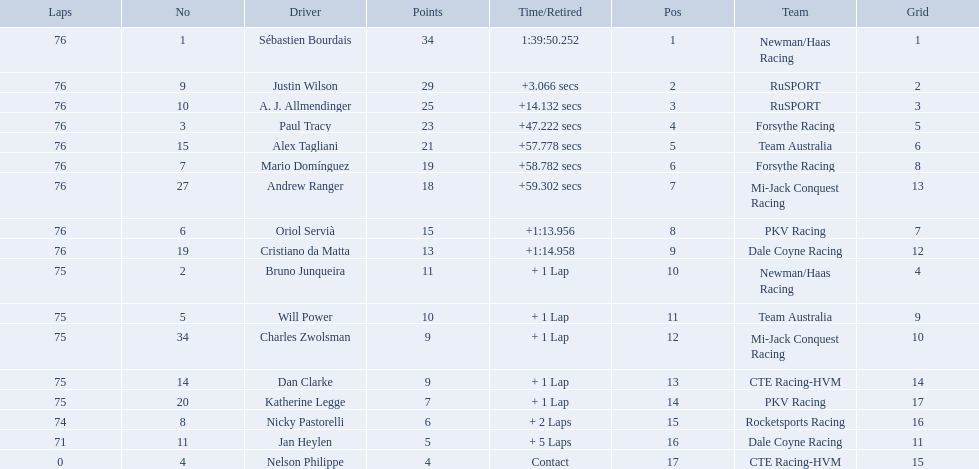Who drove during the 2006 tecate grand prix of monterrey? Sébastien Bourdais, Justin Wilson, A. J. Allmendinger, Paul Tracy, Alex Tagliani, Mario Domínguez, Andrew Ranger, Oriol Servià, Cristiano da Matta, Bruno Junqueira, Will Power, Charles Zwolsman, Dan Clarke, Katherine Legge, Nicky Pastorelli, Jan Heylen, Nelson Philippe. And what were their finishing positions? 1, 2, 3, 4, 5, 6, 7, 8, 9, 10, 11, 12, 13, 14, 15, 16, 17. Who did alex tagliani finish directly behind of? Paul Tracy. 